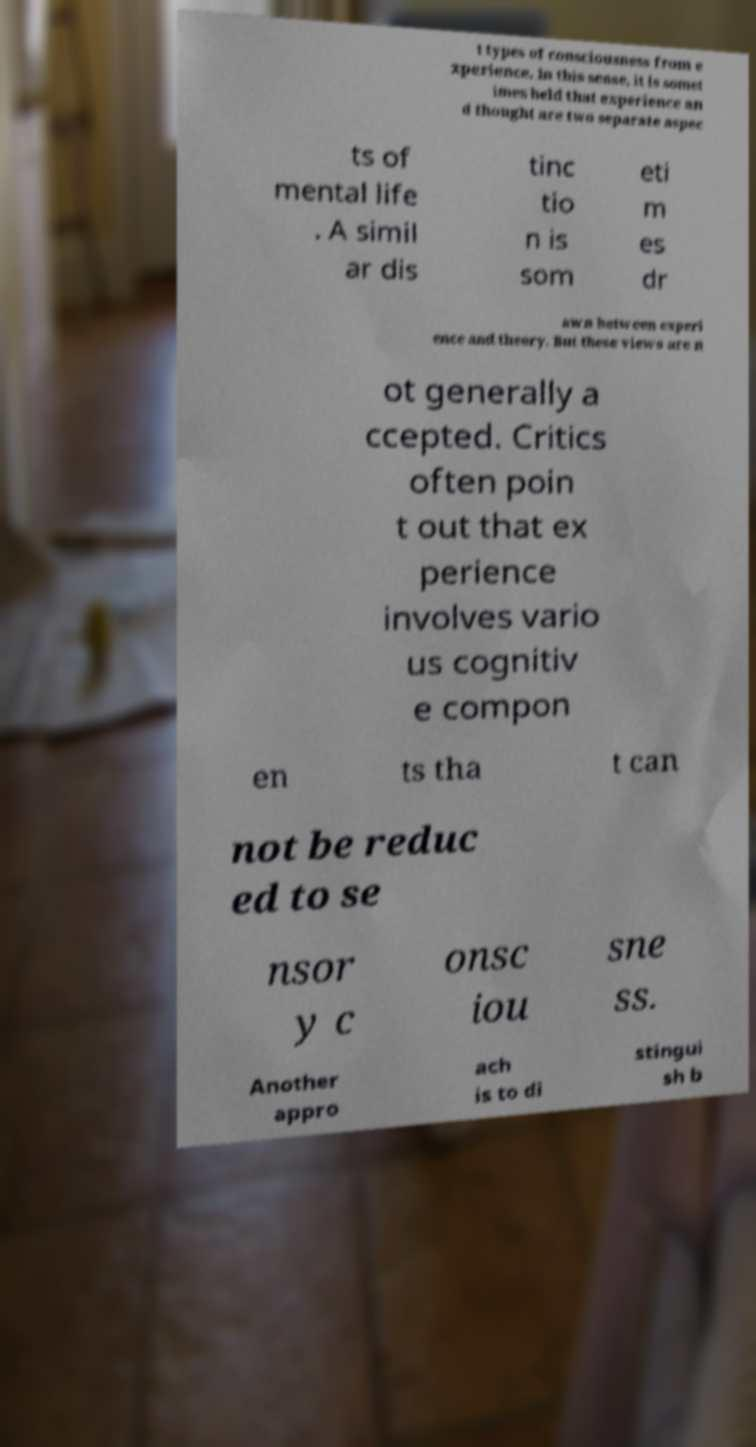Please read and relay the text visible in this image. What does it say? t types of consciousness from e xperience. In this sense, it is somet imes held that experience an d thought are two separate aspec ts of mental life . A simil ar dis tinc tio n is som eti m es dr awn between experi ence and theory. But these views are n ot generally a ccepted. Critics often poin t out that ex perience involves vario us cognitiv e compon en ts tha t can not be reduc ed to se nsor y c onsc iou sne ss. Another appro ach is to di stingui sh b 